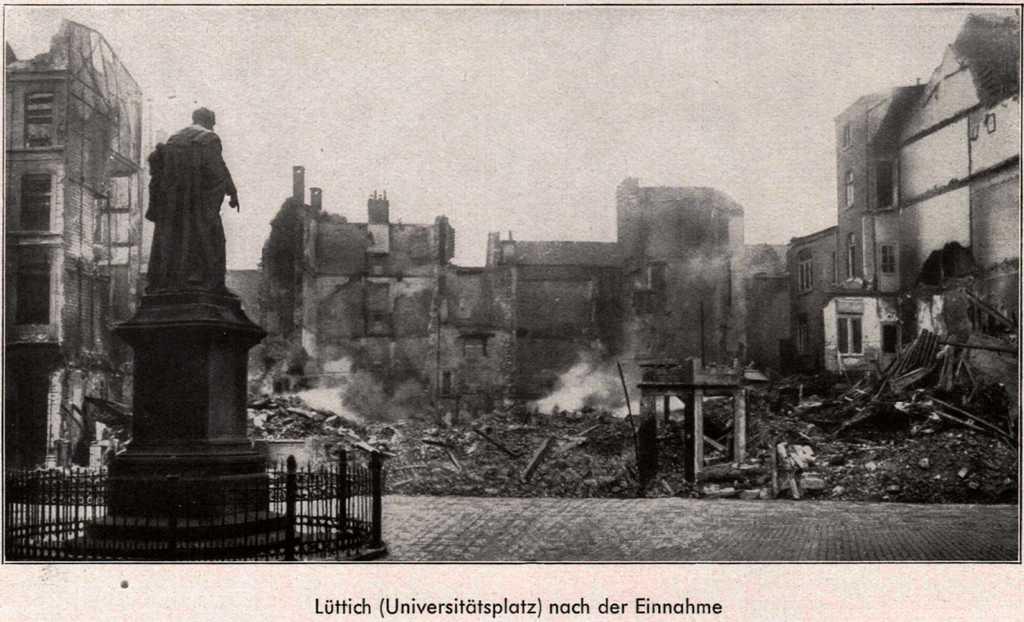How would you summarize this image in a sentence or two? It is a black and white picture, there is a sculpture and in front of the sculpture the place is completely damaged and burnt, around the sculpture there are some other buildings. 